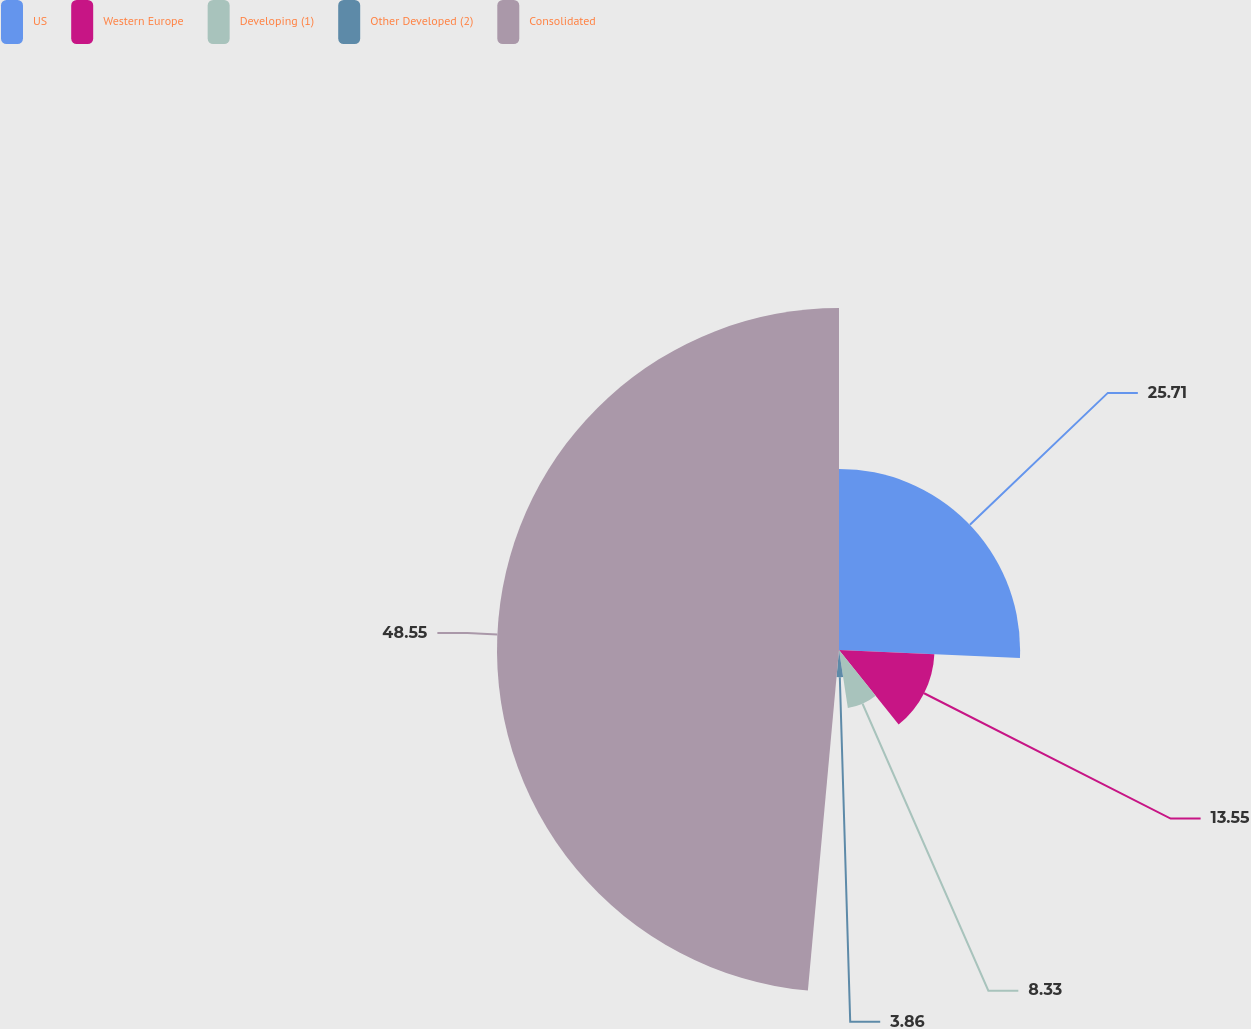<chart> <loc_0><loc_0><loc_500><loc_500><pie_chart><fcel>US<fcel>Western Europe<fcel>Developing (1)<fcel>Other Developed (2)<fcel>Consolidated<nl><fcel>25.71%<fcel>13.55%<fcel>8.33%<fcel>3.86%<fcel>48.55%<nl></chart> 